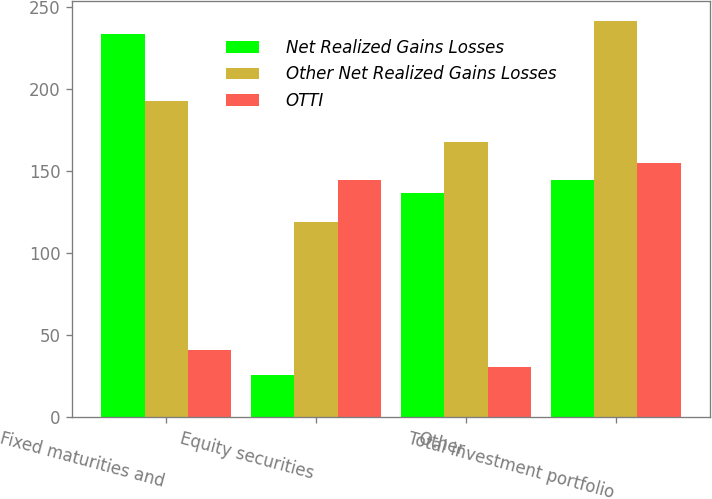Convert chart. <chart><loc_0><loc_0><loc_500><loc_500><stacked_bar_chart><ecel><fcel>Fixed maturities and<fcel>Equity securities<fcel>Other<fcel>Total investment portfolio<nl><fcel>Net Realized Gains Losses<fcel>234<fcel>26<fcel>137<fcel>145<nl><fcel>Other Net Realized Gains Losses<fcel>193<fcel>119<fcel>168<fcel>242<nl><fcel>OTTI<fcel>41<fcel>145<fcel>31<fcel>155<nl></chart> 